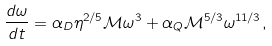<formula> <loc_0><loc_0><loc_500><loc_500>\frac { d \omega } { d t } = \alpha _ { D } \eta ^ { 2 / 5 } \mathcal { M } \omega ^ { 3 } + \alpha _ { Q } \mathcal { M } ^ { 5 / 3 } \omega ^ { 1 1 / 3 } ,</formula> 